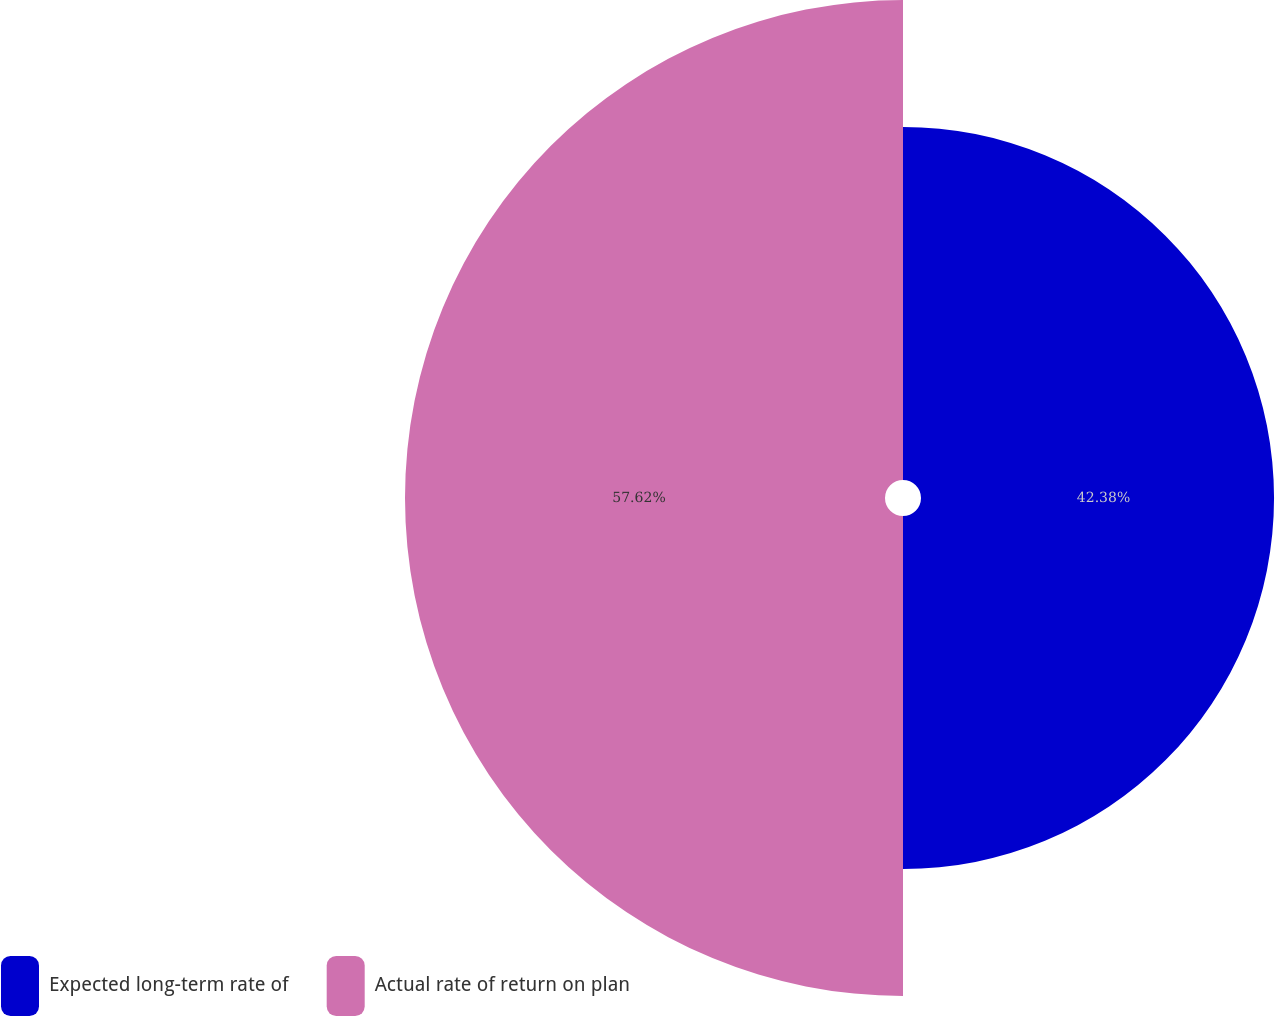<chart> <loc_0><loc_0><loc_500><loc_500><pie_chart><fcel>Expected long-term rate of<fcel>Actual rate of return on plan<nl><fcel>42.38%<fcel>57.62%<nl></chart> 